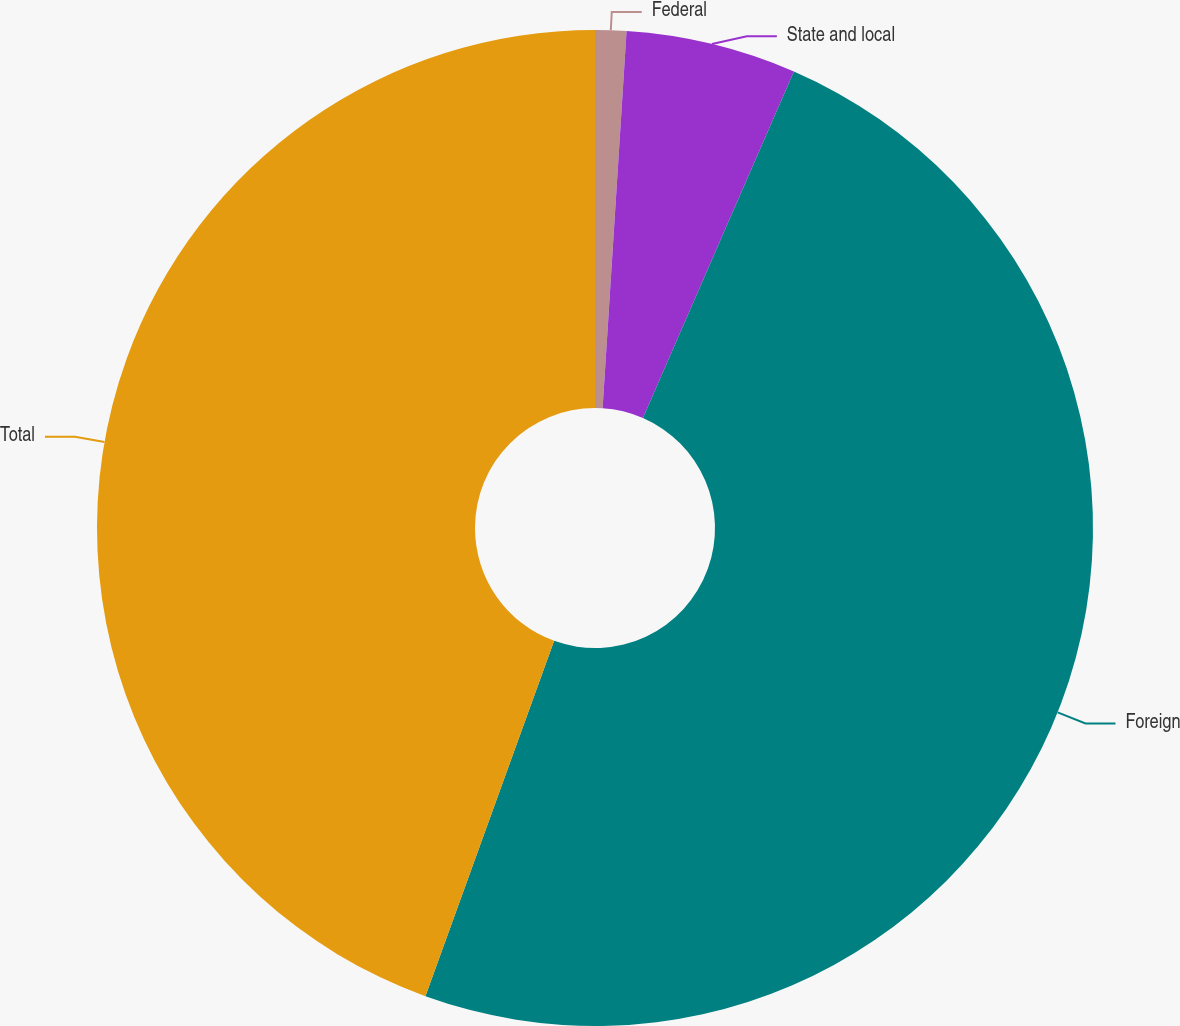Convert chart to OTSL. <chart><loc_0><loc_0><loc_500><loc_500><pie_chart><fcel>Federal<fcel>State and local<fcel>Foreign<fcel>Total<nl><fcel>1.01%<fcel>5.53%<fcel>48.99%<fcel>44.47%<nl></chart> 